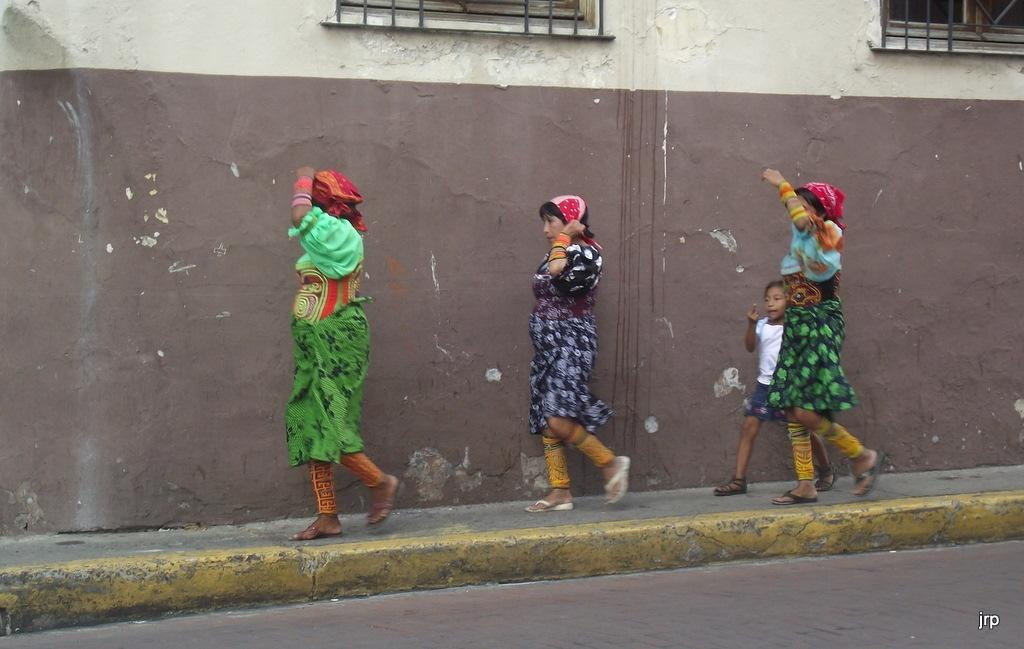How many females are present in the image? There is one girl and three women in the image. What are the women wearing on their heads? The three women are wearing red cloth on their heads. What can be seen in the background of the image? There is a wall in the background of the image. What type of flowers are being sold by the girl in the image? There are no flowers present in the image, and the girl is not selling anything. 